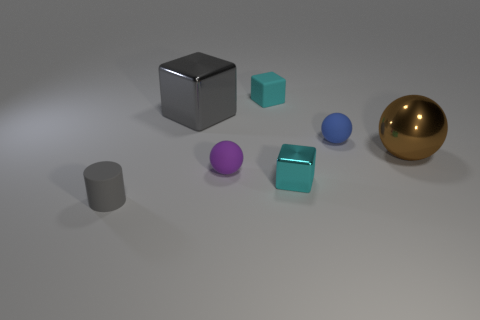What shape is the tiny object that is both on the right side of the tiny matte block and in front of the tiny blue thing? The tiny object positioned on the right side of the matte block and in front of the blue item appears to be a cube, based on its geometrically equal and square faces. 